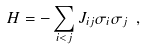<formula> <loc_0><loc_0><loc_500><loc_500>H = - \sum _ { i < j } J _ { i j } \sigma _ { i } \sigma _ { j } \ ,</formula> 